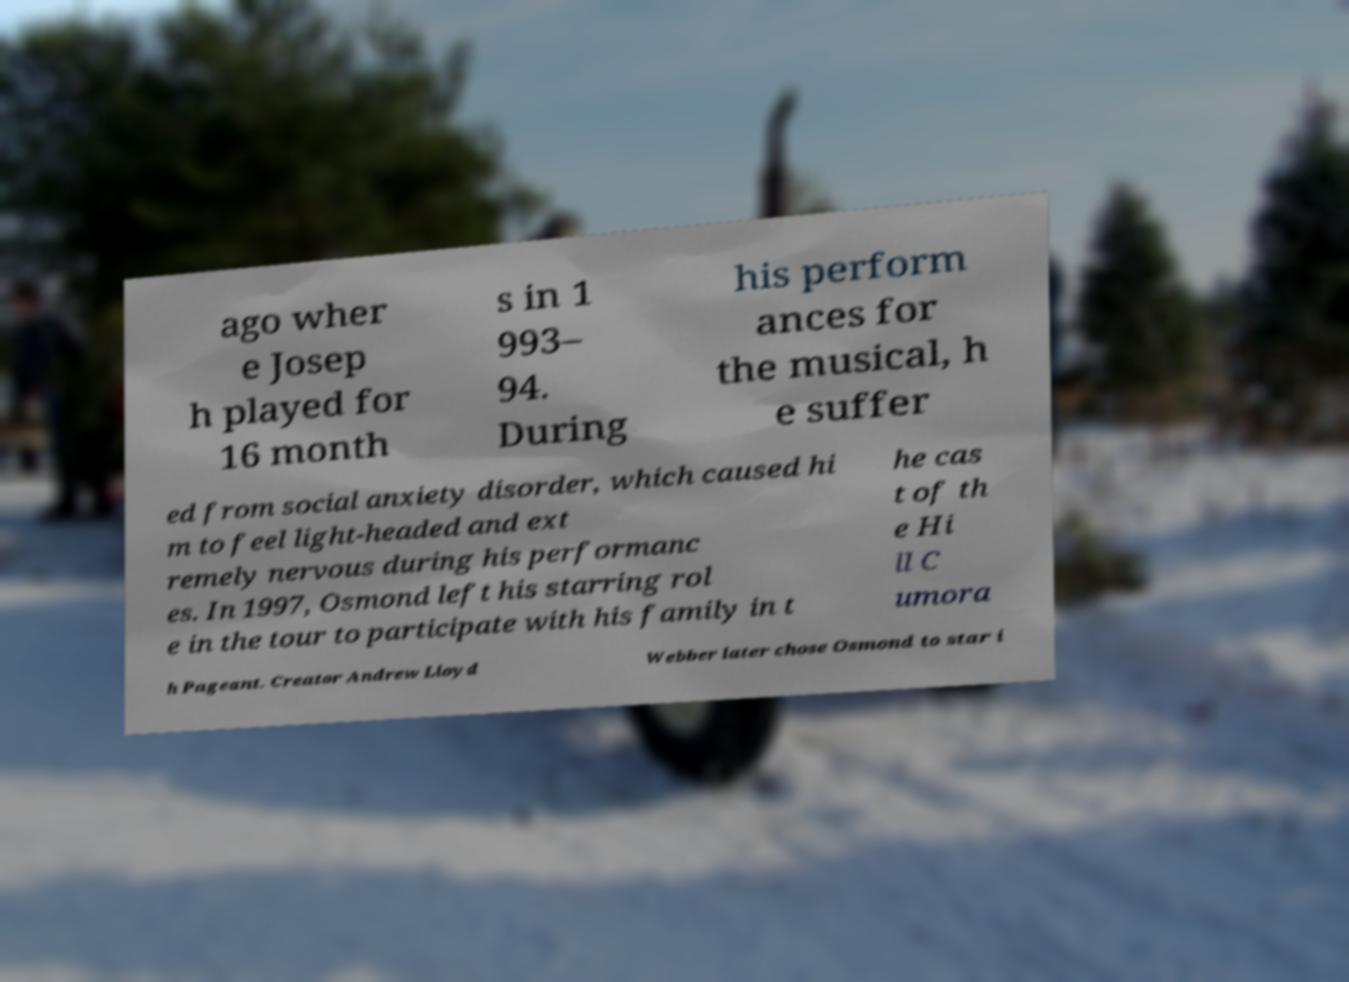Could you assist in decoding the text presented in this image and type it out clearly? ago wher e Josep h played for 16 month s in 1 993– 94. During his perform ances for the musical, h e suffer ed from social anxiety disorder, which caused hi m to feel light-headed and ext remely nervous during his performanc es. In 1997, Osmond left his starring rol e in the tour to participate with his family in t he cas t of th e Hi ll C umora h Pageant. Creator Andrew Lloyd Webber later chose Osmond to star i 